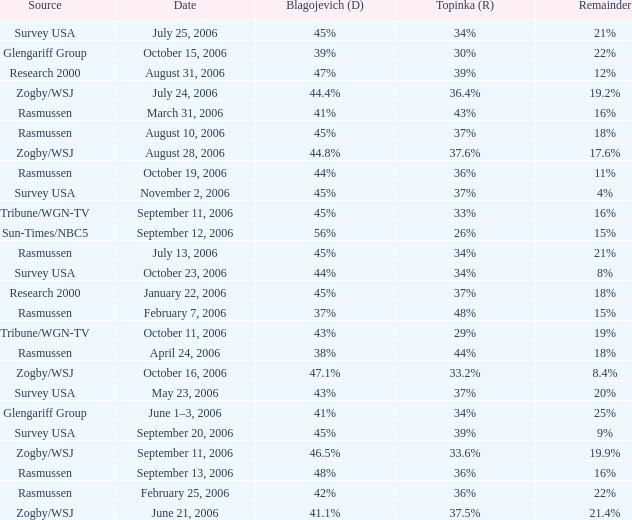Which Topinka happened on january 22, 2006? 37%. 